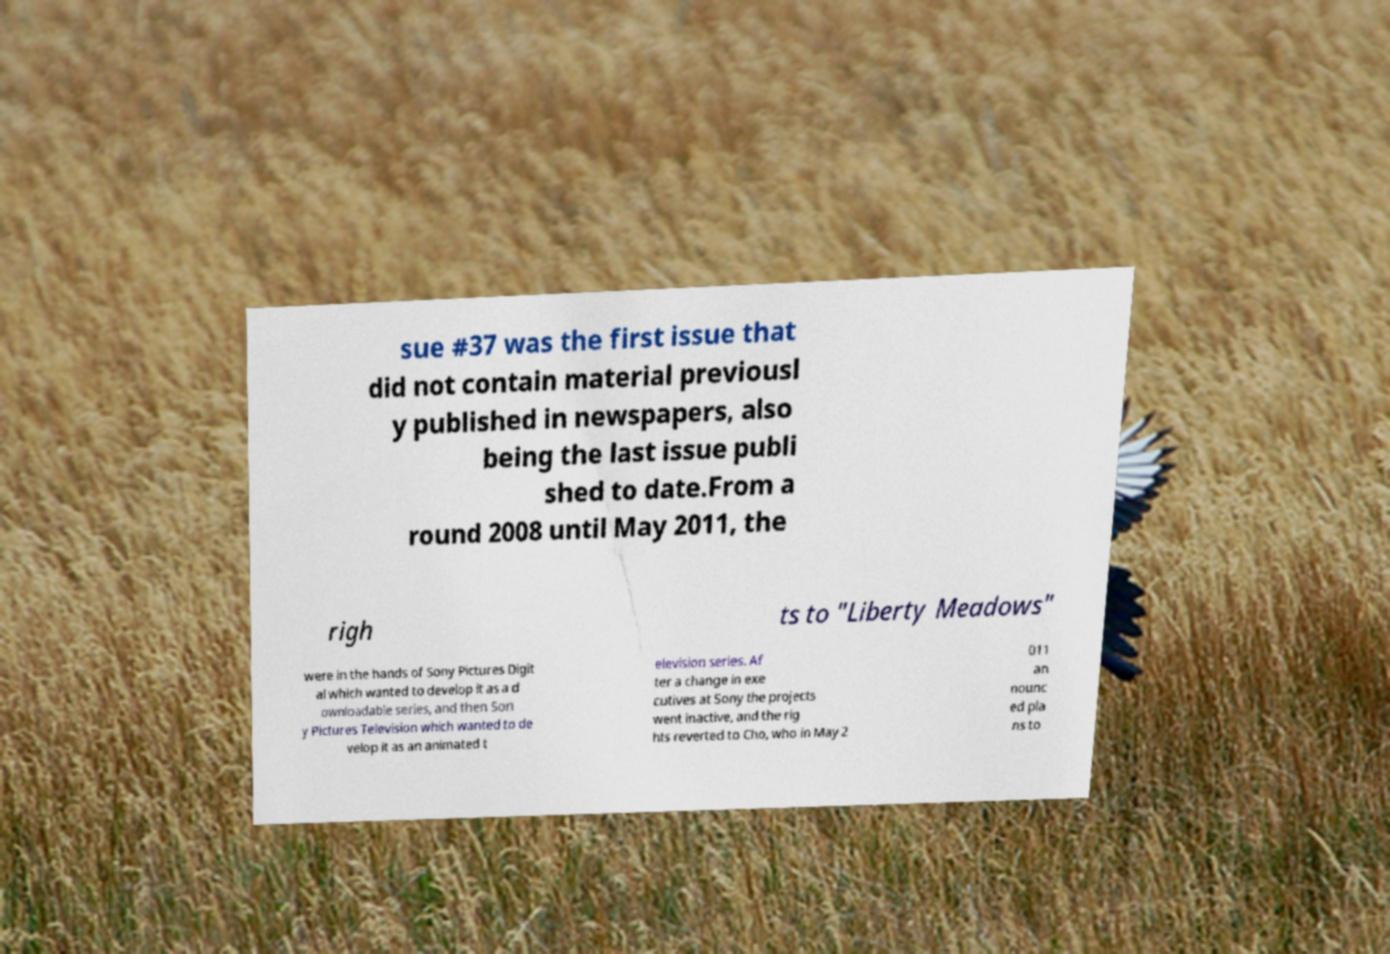Please identify and transcribe the text found in this image. sue #37 was the first issue that did not contain material previousl y published in newspapers, also being the last issue publi shed to date.From a round 2008 until May 2011, the righ ts to "Liberty Meadows" were in the hands of Sony Pictures Digit al which wanted to develop it as a d ownloadable series, and then Son y Pictures Television which wanted to de velop it as an animated t elevision series. Af ter a change in exe cutives at Sony the projects went inactive, and the rig hts reverted to Cho, who in May 2 011 an nounc ed pla ns to 